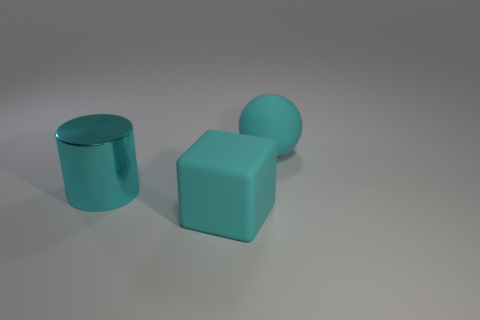There is a large shiny cylinder behind the cyan rubber cube; how many large metallic cylinders are left of it?
Your response must be concise. 0. Is there any other thing that is the same material as the large cyan cylinder?
Offer a terse response. No. There is a cyan cube that is in front of the cyan rubber object behind the big cyan rubber thing that is in front of the cyan matte ball; what is it made of?
Your response must be concise. Rubber. The thing that is both behind the cyan cube and in front of the large ball is made of what material?
Your response must be concise. Metal. Is the color of the big thing on the right side of the block the same as the object in front of the large metal thing?
Offer a terse response. Yes. What number of large cyan metallic cylinders are in front of the thing that is on the left side of the rubber thing in front of the cyan cylinder?
Offer a very short reply. 0. What number of large objects are to the left of the cyan rubber ball and behind the matte block?
Provide a succinct answer. 1. Is the number of large cyan objects that are in front of the shiny cylinder greater than the number of big gray spheres?
Give a very brief answer. Yes. What number of cyan things have the same size as the cyan cube?
Ensure brevity in your answer.  2. What number of small things are either cyan cylinders or yellow shiny cylinders?
Provide a succinct answer. 0. 